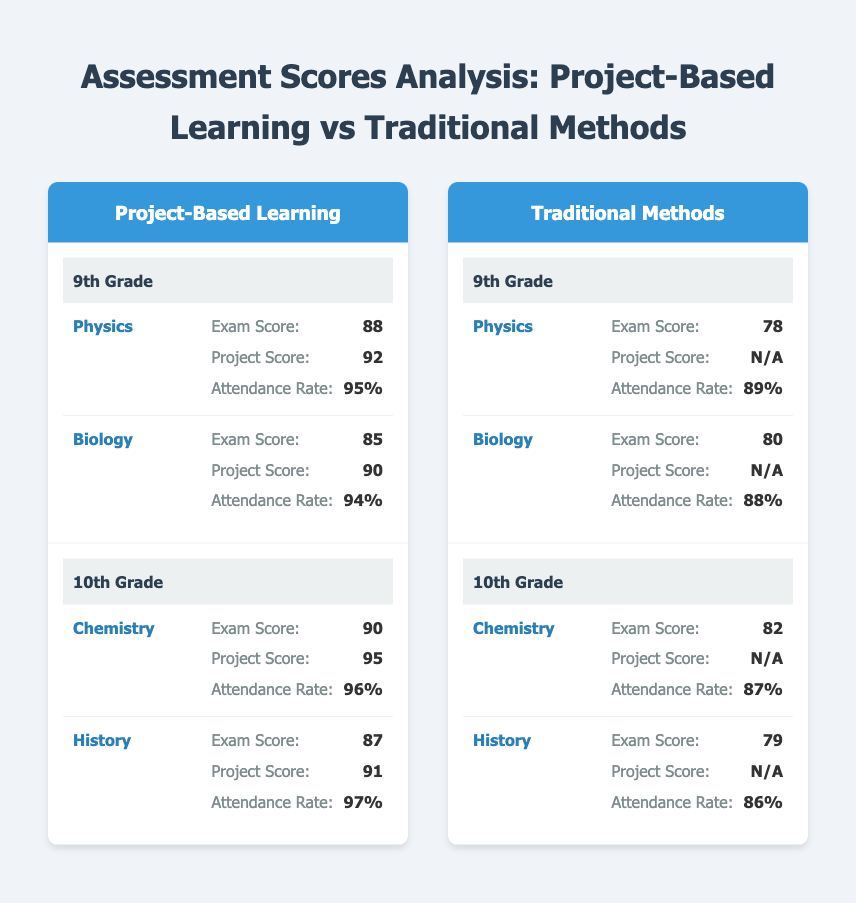What is the exam score for 10th Grade Chemistry in Project-Based Learning? The exam score for 10th Grade Chemistry in Project-Based Learning is listed directly in the table under the respective subject and grade, which is 90.
Answer: 90 What is the attendance rate for 9th Grade Biology in Traditional Methods? The attendance rate for 9th Grade Biology in Traditional Methods is provided in the table, which shows the value as 88%.
Answer: 88% Which subject had a higher project score in 9th Grade, Physics or Biology, for Project-Based Learning? The project scores for both subjects are found in the table: Physics has a project score of 92, while Biology has a project score of 90. Since 92 is greater than 90, Physics had the higher project score.
Answer: Physics What is the average exam score for 10th Grade across all learning methods? To find the average, we add the exam scores for 10th Grade in both methods: Project-Based Learning (90 + 87) gives us 177, and Traditional Methods (82 + 79) gives us 161. We then sum these: 177 + 161 = 338. There are four scores, so we divide by 4: 338 / 4 = 84.5.
Answer: 84.5 Is the attendance rate for 10th Grade History in Project-Based Learning higher than 90%? The attendance rate for 10th Grade History in Project-Based Learning is stated in the table as 97%. Since 97% is greater than 90%, the answer is yes.
Answer: Yes What is the difference in exam scores between 9th Grade Physics using Project-Based Learning and Traditional Methods? The exam score for 9th Grade Physics in Project-Based Learning is 88, while in Traditional Methods it is 78. To find the difference, we subtract 78 from 88: 88 - 78 = 10.
Answer: 10 Which learning method had a higher average attendance rate for 9th Grade? We look at the attendance rates for both learning methods in 9th Grade: Project-Based Learning has 95% (Physics) and 94% (Biology), averaging to (95 + 94) / 2 = 94.5%. Traditional Methods has 89% (Physics) and 88% (Biology), averaging to (89 + 88) / 2 = 88.5%. Since 94.5% is greater than 88.5%, Project-Based Learning had a higher average attendance rate.
Answer: Project-Based Learning What is the Project Score for 10th Grade History using Project-Based Learning? The Project Score for 10th Grade History in the Project-Based Learning section is provided directly in the table, which states it is 91.
Answer: 91 Are there any subjects in 10th Grade that have a Project Score listed under Traditional Methods? The table shows that all subjects in 10th Grade under Traditional Methods have marked "N/A" for the Project Score. Therefore, there are no subjects with a Project Score listed.
Answer: No 